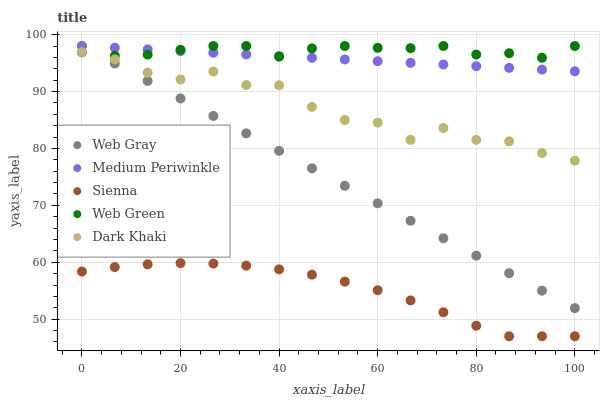Does Sienna have the minimum area under the curve?
Answer yes or no. Yes. Does Web Green have the maximum area under the curve?
Answer yes or no. Yes. Does Dark Khaki have the minimum area under the curve?
Answer yes or no. No. Does Dark Khaki have the maximum area under the curve?
Answer yes or no. No. Is Web Gray the smoothest?
Answer yes or no. Yes. Is Dark Khaki the roughest?
Answer yes or no. Yes. Is Dark Khaki the smoothest?
Answer yes or no. No. Is Web Gray the roughest?
Answer yes or no. No. Does Sienna have the lowest value?
Answer yes or no. Yes. Does Dark Khaki have the lowest value?
Answer yes or no. No. Does Web Green have the highest value?
Answer yes or no. Yes. Does Dark Khaki have the highest value?
Answer yes or no. No. Is Sienna less than Web Green?
Answer yes or no. Yes. Is Web Green greater than Sienna?
Answer yes or no. Yes. Does Web Gray intersect Medium Periwinkle?
Answer yes or no. Yes. Is Web Gray less than Medium Periwinkle?
Answer yes or no. No. Is Web Gray greater than Medium Periwinkle?
Answer yes or no. No. Does Sienna intersect Web Green?
Answer yes or no. No. 